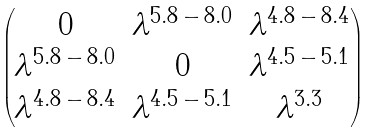<formula> <loc_0><loc_0><loc_500><loc_500>\begin{pmatrix} 0 & \lambda ^ { 5 . 8 \, - \, 8 . 0 } & \lambda ^ { 4 . 8 \, - \, 8 . 4 } \\ \lambda ^ { 5 . 8 \, - \, 8 . 0 } & 0 & \lambda ^ { 4 . 5 \, - \, 5 . 1 } \\ \lambda ^ { 4 . 8 \, - \, 8 . 4 } & \lambda ^ { 4 . 5 \, - \, 5 . 1 } & \lambda ^ { 3 . 3 } \end{pmatrix}</formula> 